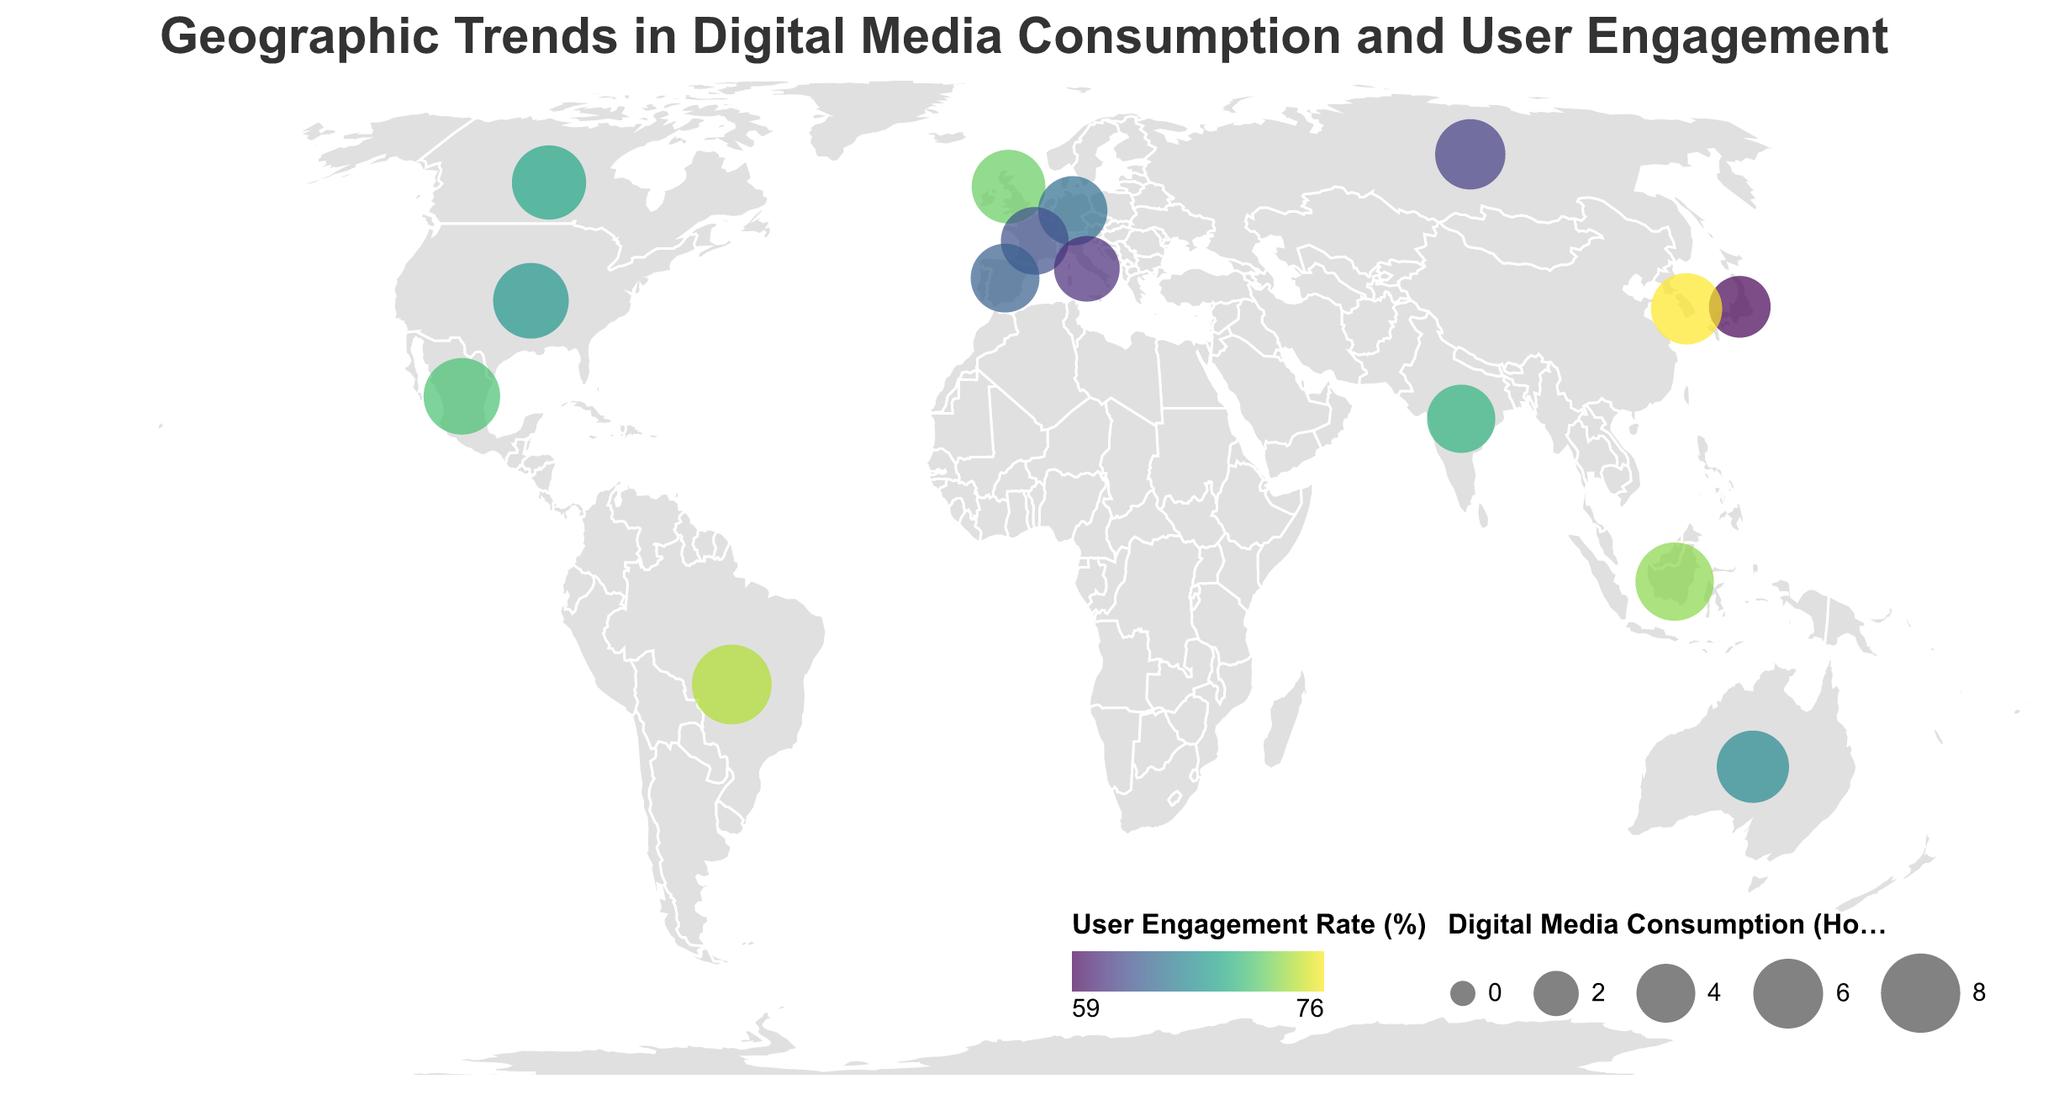Which country has the highest digital media consumption in hours per day? To determine this, look for the country with the largest circle representation on the map since circle size indicates digital media consumption in hours per day.
Answer: Brazil Which country has the lowest user engagement rate? Check for the country that has the least intense color on the color scale, as the color represents user engagement rate.
Answer: Japan What is the approximate digital media consumption in hours per day for the United States? Hover over or locate the United States data point on the map and refer to the tooltip or circle size.
Answer: 7.2 How does the mobile vs desktop usage ratio in India compare to that in Japan? Find India and Japan on the map and compare their respective mobile vs desktop usage ratios, looking for the specific ratio numbers.
Answer: India has a higher ratio (5.2 vs. 4.1) Which countries have a user engagement rate greater than 70%? Identify the countries that have a color intensity corresponding to a user engagement rate greater than 70% from those provided within the legend colorscale.
Answer: United Kingdom, Brazil, India, South Korea, Mexico, Indonesia What is the general trend in mobile vs desktop usage ratio across different countries? By scanning multiple data points on the map, check the variation and range in mobile vs desktop usage ratios as illustrated by the data.
Answer: Mobile usage generally outweighs desktop usage in all countries What is the sum of digital media consumption hours per day for France and Germany combined? Locate the circles for France and Germany on the map, then add their digital media consumption values. This requires summing up France (5.6) and Germany (5.9).
Answer: 11.5 Which country has the highest user engagement rate and what is its digital media consumption in hours per day? Identify the country with the most intense color indicating it has the highest user engagement rate using the color encoding and check its digital media consumption by referring to the circle size or tooltip.
Answer: South Korea, 6.3 How does the digital media consumption in hours per day and user engagement rate in Brazil compare to that in Mexico? Locate Brazil and Mexico on the map and compare both the circle sizes (hours per day) and color intensities (user engagement rate) for each.
Answer: Brazil has higher digital media consumption (8.1 vs. 7.4) and a higher user engagement rate (74% vs. 71%) Is there any country with an equal user engagement rate and digital media consumption hours? By examining the map, check the data points to see if there is any correspondence between user engagement rate percentage and digital media consumption hours.
Answer: No 